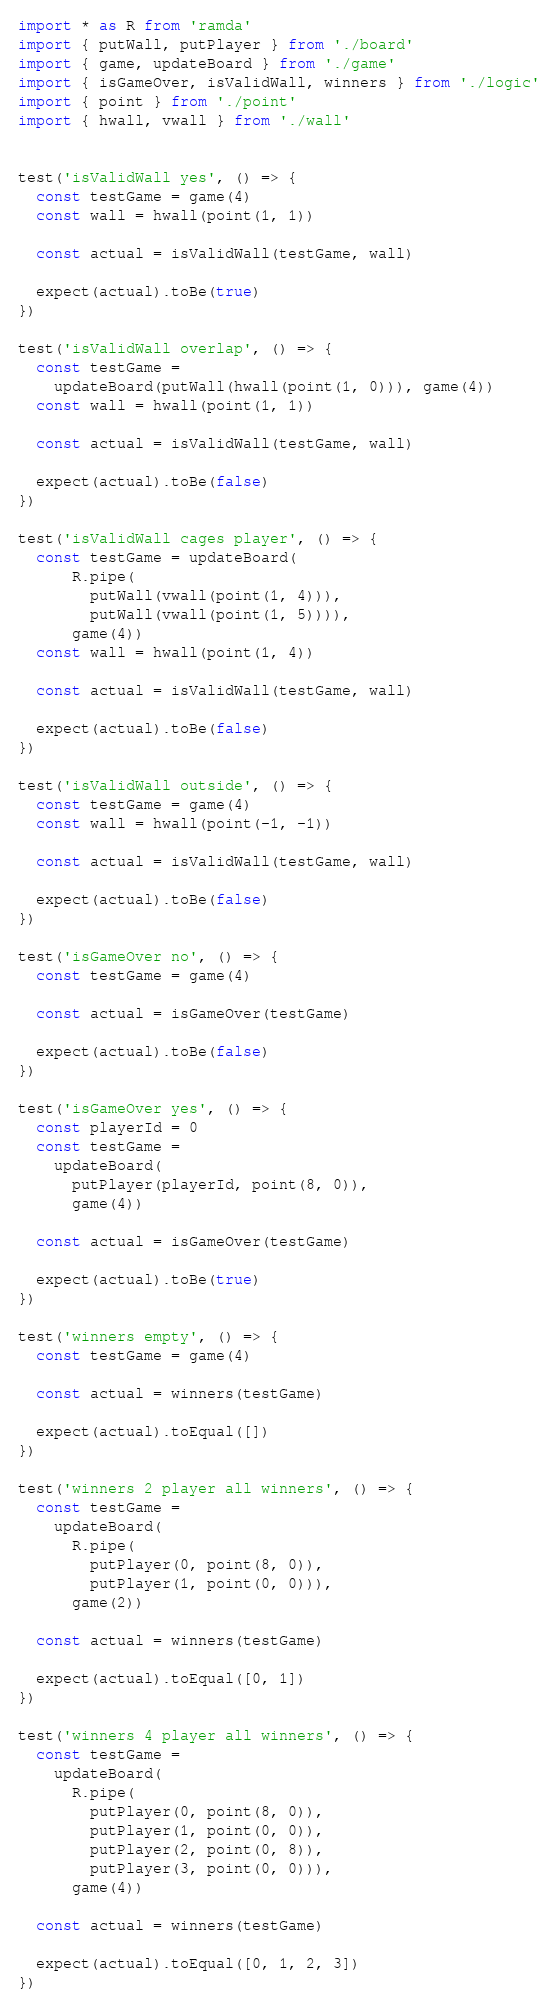Convert code to text. <code><loc_0><loc_0><loc_500><loc_500><_JavaScript_>import * as R from 'ramda'
import { putWall, putPlayer } from './board'
import { game, updateBoard } from './game'
import { isGameOver, isValidWall, winners } from './logic'
import { point } from './point'
import { hwall, vwall } from './wall'


test('isValidWall yes', () => {
  const testGame = game(4)
  const wall = hwall(point(1, 1))

  const actual = isValidWall(testGame, wall)

  expect(actual).toBe(true)
})

test('isValidWall overlap', () => {
  const testGame =
    updateBoard(putWall(hwall(point(1, 0))), game(4))
  const wall = hwall(point(1, 1))

  const actual = isValidWall(testGame, wall)

  expect(actual).toBe(false)
})

test('isValidWall cages player', () => {
  const testGame = updateBoard(
      R.pipe(
        putWall(vwall(point(1, 4))),
        putWall(vwall(point(1, 5)))),
      game(4))
  const wall = hwall(point(1, 4))

  const actual = isValidWall(testGame, wall)

  expect(actual).toBe(false)
})

test('isValidWall outside', () => {
  const testGame = game(4)
  const wall = hwall(point(-1, -1))

  const actual = isValidWall(testGame, wall)

  expect(actual).toBe(false)
})

test('isGameOver no', () => {
  const testGame = game(4)

  const actual = isGameOver(testGame)

  expect(actual).toBe(false)
})

test('isGameOver yes', () => {
  const playerId = 0
  const testGame =
    updateBoard(
      putPlayer(playerId, point(8, 0)),
      game(4))

  const actual = isGameOver(testGame)

  expect(actual).toBe(true)
})

test('winners empty', () => {
  const testGame = game(4)

  const actual = winners(testGame)

  expect(actual).toEqual([])
})

test('winners 2 player all winners', () => {
  const testGame =
    updateBoard(
      R.pipe(
        putPlayer(0, point(8, 0)),
        putPlayer(1, point(0, 0))),
      game(2))

  const actual = winners(testGame)

  expect(actual).toEqual([0, 1])
})

test('winners 4 player all winners', () => {
  const testGame =
    updateBoard(
      R.pipe(
        putPlayer(0, point(8, 0)),
        putPlayer(1, point(0, 0)),
        putPlayer(2, point(0, 8)),
        putPlayer(3, point(0, 0))),
      game(4))

  const actual = winners(testGame)

  expect(actual).toEqual([0, 1, 2, 3])
})
</code> 